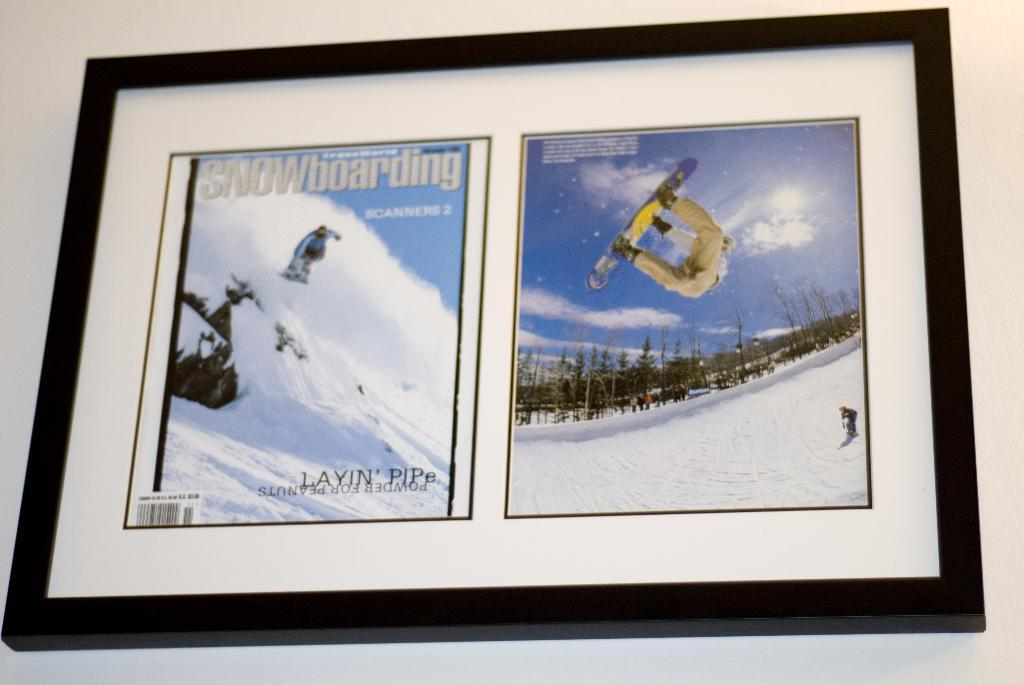<image>
Give a short and clear explanation of the subsequent image. Two framed magazines of snowboarding featuring two different athletes on the covers. 